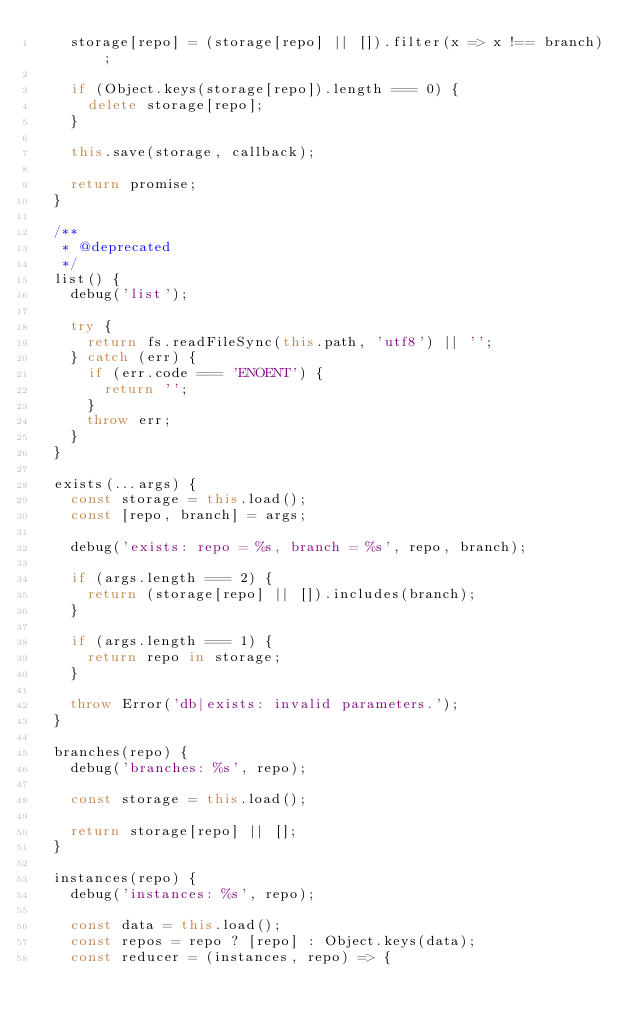Convert code to text. <code><loc_0><loc_0><loc_500><loc_500><_JavaScript_>    storage[repo] = (storage[repo] || []).filter(x => x !== branch);

    if (Object.keys(storage[repo]).length === 0) {
      delete storage[repo];
    }

    this.save(storage, callback);

    return promise;
  }

  /**
   * @deprecated
   */
  list() {
    debug('list');

    try {
      return fs.readFileSync(this.path, 'utf8') || '';
    } catch (err) {
      if (err.code === 'ENOENT') {
        return '';
      }
      throw err;
    }
  }

  exists(...args) {
    const storage = this.load();
    const [repo, branch] = args;

    debug('exists: repo = %s, branch = %s', repo, branch);

    if (args.length === 2) {
      return (storage[repo] || []).includes(branch);
    }

    if (args.length === 1) {
      return repo in storage;
    }

    throw Error('db|exists: invalid parameters.');
  }

  branches(repo) {
    debug('branches: %s', repo);

    const storage = this.load();

    return storage[repo] || [];
  }

  instances(repo) {
    debug('instances: %s', repo);

    const data = this.load();
    const repos = repo ? [repo] : Object.keys(data);
    const reducer = (instances, repo) => {</code> 